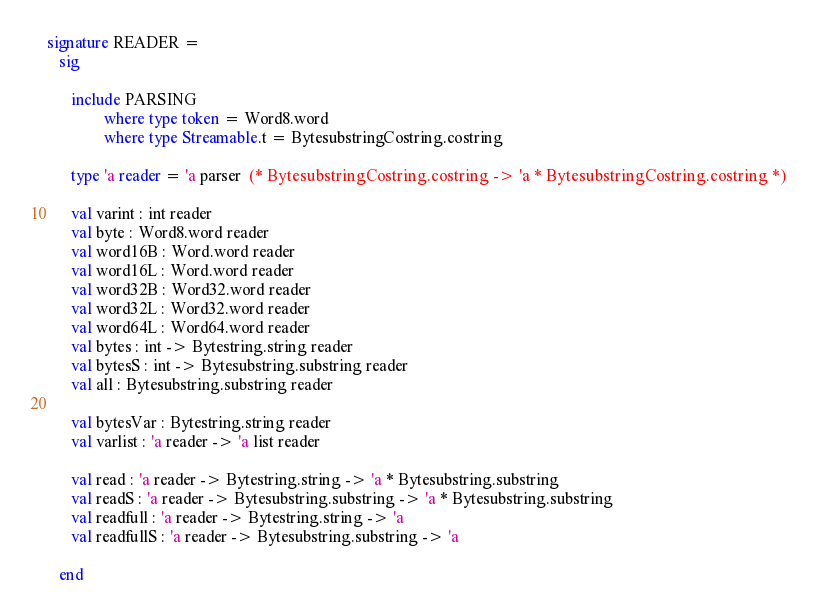Convert code to text. <code><loc_0><loc_0><loc_500><loc_500><_SML_>
signature READER =
   sig

      include PARSING
              where type token = Word8.word
              where type Streamable.t = BytesubstringCostring.costring

      type 'a reader = 'a parser  (* BytesubstringCostring.costring -> 'a * BytesubstringCostring.costring *)

      val varint : int reader
      val byte : Word8.word reader
      val word16B : Word.word reader
      val word16L : Word.word reader
      val word32B : Word32.word reader
      val word32L : Word32.word reader
      val word64L : Word64.word reader
      val bytes : int -> Bytestring.string reader
      val bytesS : int -> Bytesubstring.substring reader
      val all : Bytesubstring.substring reader

      val bytesVar : Bytestring.string reader
      val varlist : 'a reader -> 'a list reader

      val read : 'a reader -> Bytestring.string -> 'a * Bytesubstring.substring
      val readS : 'a reader -> Bytesubstring.substring -> 'a * Bytesubstring.substring
      val readfull : 'a reader -> Bytestring.string -> 'a
      val readfullS : 'a reader -> Bytesubstring.substring -> 'a

   end
</code> 